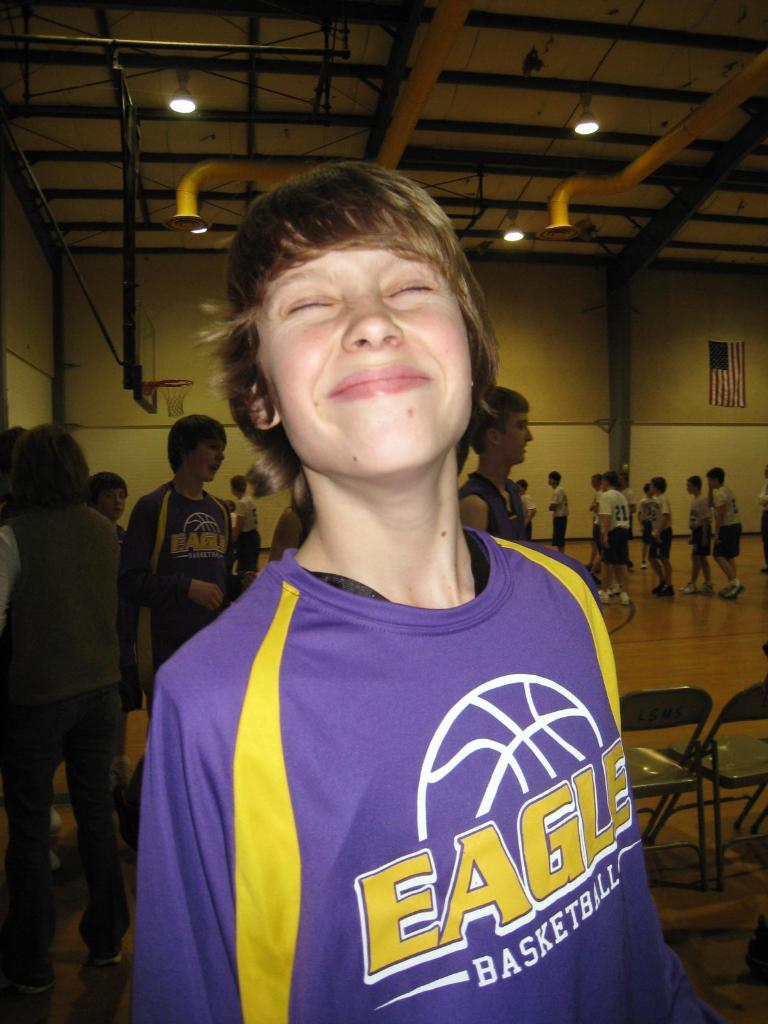<image>
Offer a succinct explanation of the picture presented. A boy wearing an Eagles Basketball jersey is smiling. 